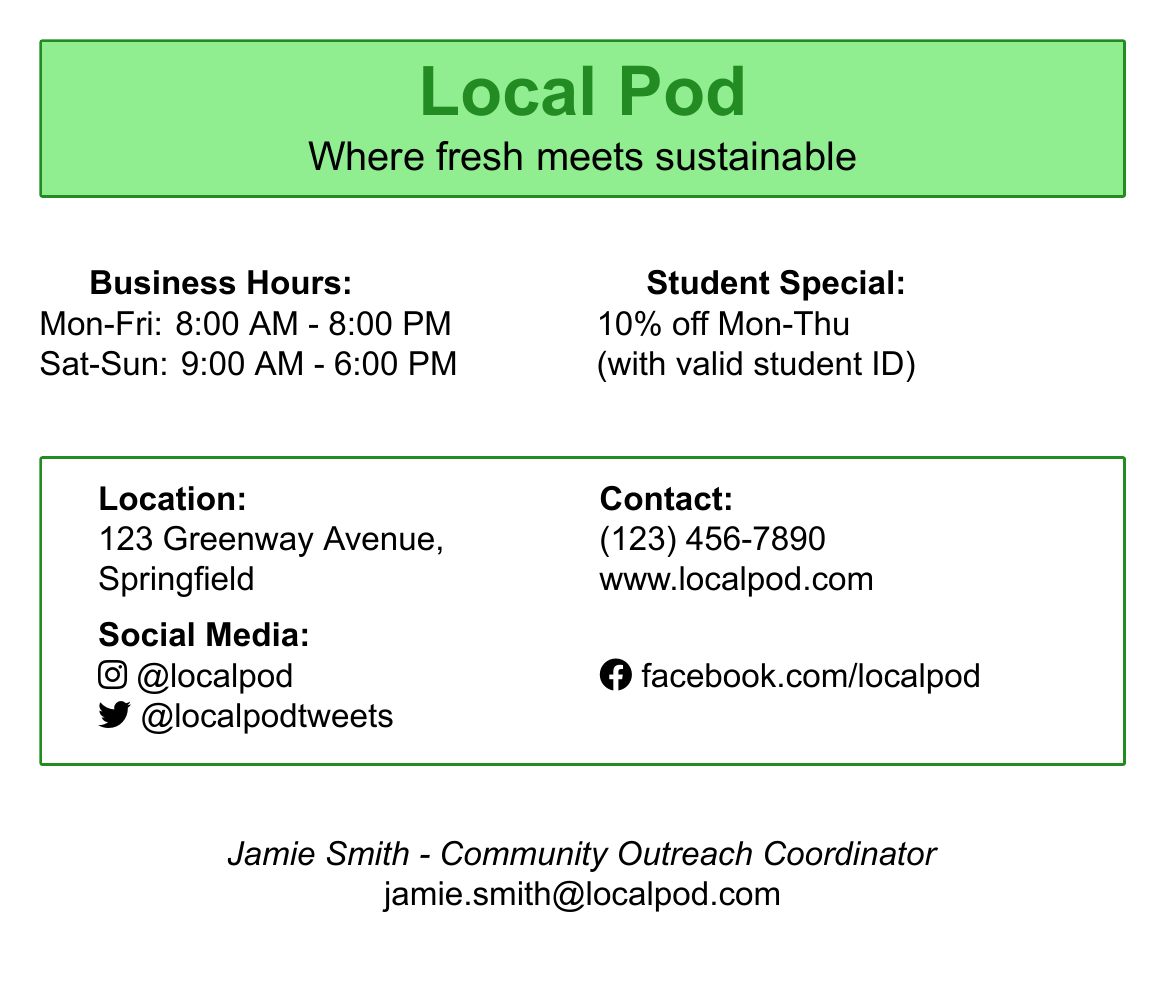What are the business hours on Saturday? The document states the business hours specifically for Saturday, which are from 9:00 AM to 6:00 PM.
Answer: 9:00 AM - 6:00 PM What discount do students get? The document mentions the special offer for students, indicating they receive a certain percentage off their purchases.
Answer: 10% off What days can students use the special discount? The document specifies the days of the week when the student discount is applicable, which requires some reasoning about when the discount is active.
Answer: Mon-Thu What is the location of Local Pod? The document provides an address for the Local Pod, identifying where it is located in Springfield.
Answer: 123 Greenway Avenue Who is the Community Outreach Coordinator? The document includes the name and title of the person responsible for community outreach at Local Pod.
Answer: Jamie Smith What is the contact number for Local Pod? The document lists a specific contact number for customer inquiries at Local Pod.
Answer: (123) 456-7890 What type of business is Local Pod focused on? The document provides a tagline that indicates the focus and mission of Local Pod in the context of food.
Answer: Sustainable food systems What is the website for Local Pod? The document includes a website address where more information about Local Pod can be found.
Answer: www.localpod.com What social media platform is Local Pod active on? The document states specific social media handles, indicating Local Pod’s presence on various platforms.
Answer: Instagram, Facebook, Twitter 